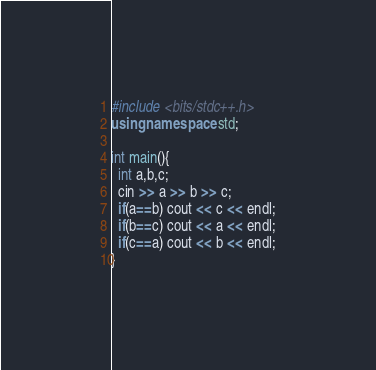Convert code to text. <code><loc_0><loc_0><loc_500><loc_500><_C++_>#include <bits/stdc++.h>
using namespace std;

int main(){
  int a,b,c;
  cin >> a >> b >> c;
  if(a==b) cout << c << endl;
  if(b==c) cout << a << endl;
  if(c==a) cout << b << endl;
}
</code> 